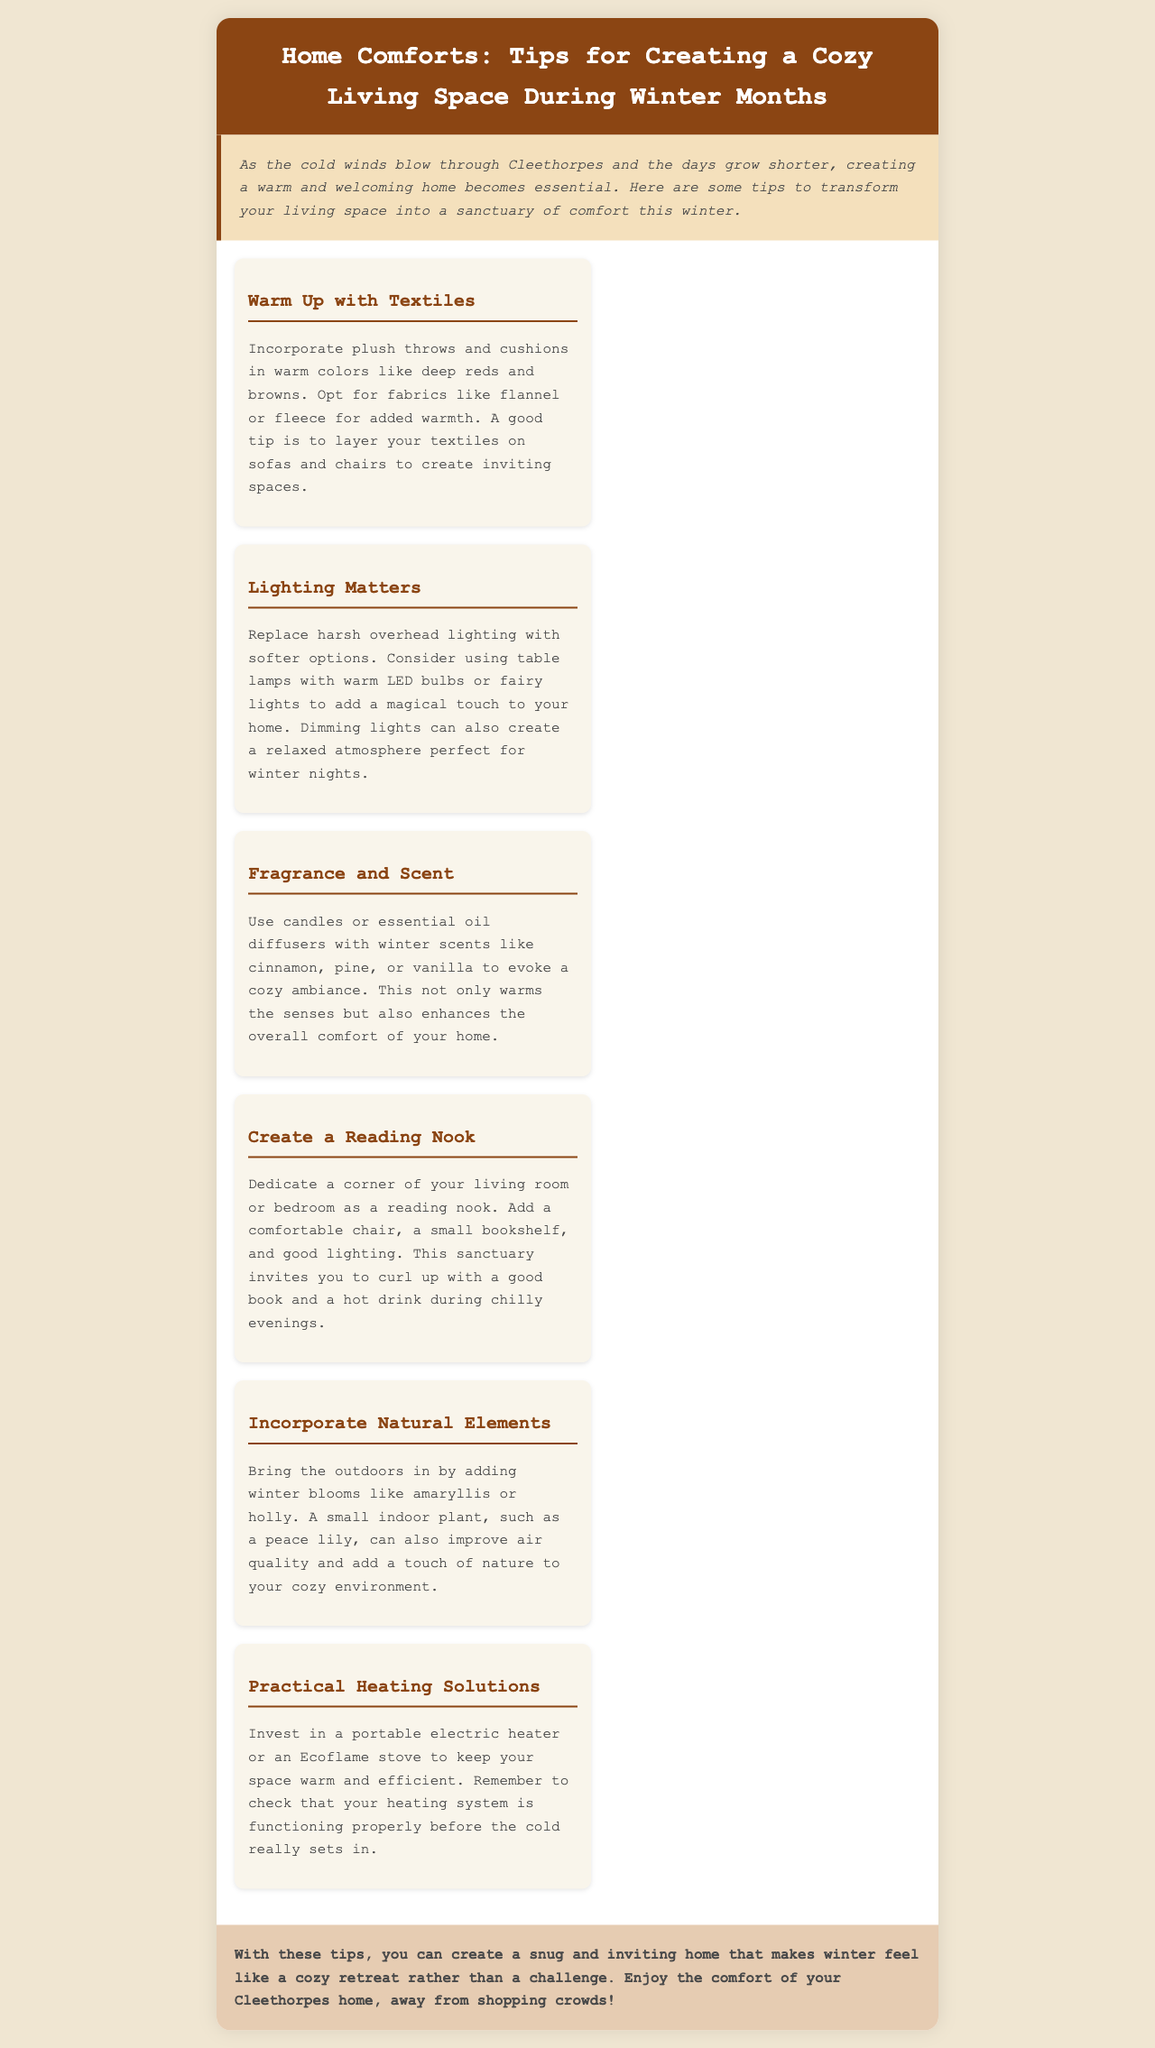what is the title of the brochure? The title is found at the top of the document in a prominent header.
Answer: Home Comforts: Tips for Creating a Cozy Living Space During Winter Months what type of fabrics are suggested for throws and cushions? The document specifies the types of fabrics recommended for comfort during winter.
Answer: flannel or fleece which scent is recommended for creating a cozy ambiance? The document lists certain scents that can enhance the atmosphere in your home.
Answer: cinnamon, pine, or vanilla what is one practical heating solution mentioned? The brochure suggests practical heating solutions for maintaining warmth in winter.
Answer: portable electric heater how can you improve air quality in your home? The document mentions a specific type of plant recommended for improving air quality.
Answer: peace lily where should you create a reading nook? The brochure suggests a specific location in the home for setting up a reading nook.
Answer: living room or bedroom what color tones are advised for textiles? The document refers to color preferences for upholstery to evoke warmth.
Answer: deep reds and browns why should you replace harsh overhead lighting? The document advises on lighting changes for a cozy atmosphere during winter.
Answer: to create a relaxed atmosphere 